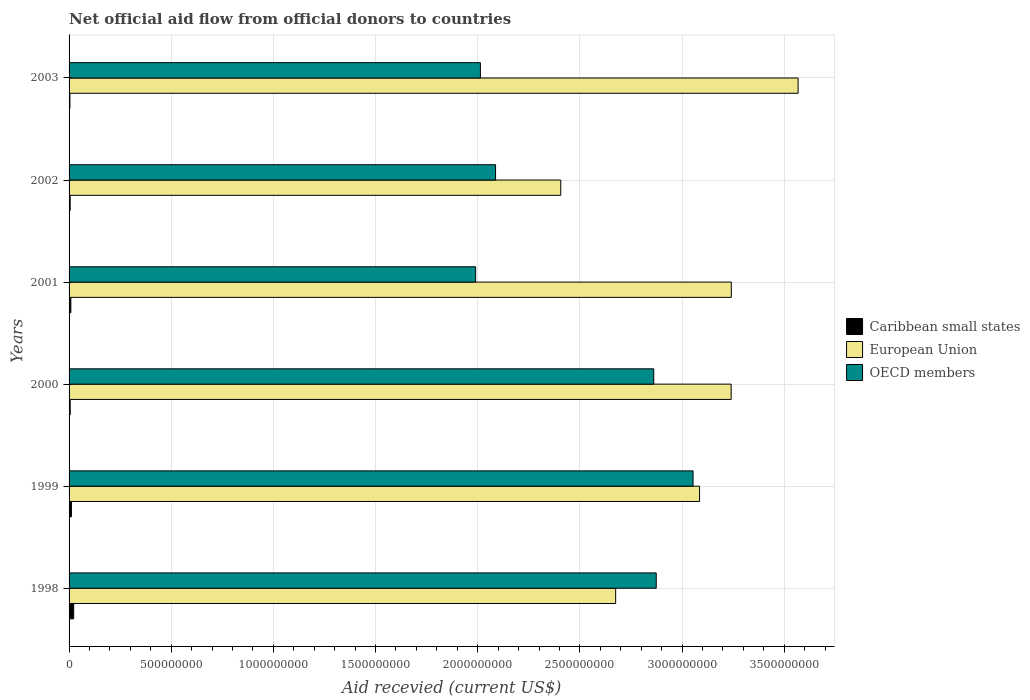How many groups of bars are there?
Offer a very short reply. 6. Are the number of bars per tick equal to the number of legend labels?
Your response must be concise. Yes. Are the number of bars on each tick of the Y-axis equal?
Your answer should be compact. Yes. How many bars are there on the 3rd tick from the bottom?
Ensure brevity in your answer.  3. What is the label of the 1st group of bars from the top?
Offer a terse response. 2003. What is the total aid received in European Union in 2003?
Provide a short and direct response. 3.57e+09. Across all years, what is the maximum total aid received in Caribbean small states?
Your response must be concise. 2.26e+07. Across all years, what is the minimum total aid received in OECD members?
Ensure brevity in your answer.  1.99e+09. In which year was the total aid received in OECD members minimum?
Your answer should be compact. 2001. What is the total total aid received in OECD members in the graph?
Provide a succinct answer. 1.49e+1. What is the difference between the total aid received in OECD members in 2002 and that in 2003?
Ensure brevity in your answer.  7.41e+07. What is the difference between the total aid received in Caribbean small states in 1998 and the total aid received in OECD members in 2001?
Ensure brevity in your answer.  -1.97e+09. What is the average total aid received in Caribbean small states per year?
Your answer should be compact. 9.62e+06. In the year 2002, what is the difference between the total aid received in European Union and total aid received in Caribbean small states?
Provide a succinct answer. 2.40e+09. In how many years, is the total aid received in European Union greater than 700000000 US$?
Make the answer very short. 6. What is the ratio of the total aid received in Caribbean small states in 1998 to that in 2001?
Provide a short and direct response. 2.6. What is the difference between the highest and the second highest total aid received in OECD members?
Your response must be concise. 1.80e+08. What is the difference between the highest and the lowest total aid received in European Union?
Provide a short and direct response. 1.16e+09. What does the 2nd bar from the top in 2001 represents?
Your answer should be very brief. European Union. What does the 2nd bar from the bottom in 2000 represents?
Your response must be concise. European Union. How many bars are there?
Provide a succinct answer. 18. What is the difference between two consecutive major ticks on the X-axis?
Ensure brevity in your answer.  5.00e+08. Are the values on the major ticks of X-axis written in scientific E-notation?
Offer a terse response. No. Where does the legend appear in the graph?
Give a very brief answer. Center right. What is the title of the graph?
Give a very brief answer. Net official aid flow from official donors to countries. Does "Curacao" appear as one of the legend labels in the graph?
Make the answer very short. No. What is the label or title of the X-axis?
Ensure brevity in your answer.  Aid recevied (current US$). What is the label or title of the Y-axis?
Offer a terse response. Years. What is the Aid recevied (current US$) of Caribbean small states in 1998?
Provide a succinct answer. 2.26e+07. What is the Aid recevied (current US$) of European Union in 1998?
Your answer should be compact. 2.68e+09. What is the Aid recevied (current US$) of OECD members in 1998?
Your answer should be compact. 2.87e+09. What is the Aid recevied (current US$) of Caribbean small states in 1999?
Ensure brevity in your answer.  1.16e+07. What is the Aid recevied (current US$) of European Union in 1999?
Your answer should be very brief. 3.09e+09. What is the Aid recevied (current US$) in OECD members in 1999?
Make the answer very short. 3.05e+09. What is the Aid recevied (current US$) in Caribbean small states in 2000?
Your answer should be compact. 5.47e+06. What is the Aid recevied (current US$) in European Union in 2000?
Offer a very short reply. 3.24e+09. What is the Aid recevied (current US$) of OECD members in 2000?
Provide a short and direct response. 2.86e+09. What is the Aid recevied (current US$) of Caribbean small states in 2001?
Provide a short and direct response. 8.68e+06. What is the Aid recevied (current US$) in European Union in 2001?
Offer a very short reply. 3.24e+09. What is the Aid recevied (current US$) in OECD members in 2001?
Offer a very short reply. 1.99e+09. What is the Aid recevied (current US$) in Caribbean small states in 2002?
Ensure brevity in your answer.  5.32e+06. What is the Aid recevied (current US$) of European Union in 2002?
Provide a succinct answer. 2.41e+09. What is the Aid recevied (current US$) of OECD members in 2002?
Ensure brevity in your answer.  2.09e+09. What is the Aid recevied (current US$) of Caribbean small states in 2003?
Provide a succinct answer. 4.07e+06. What is the Aid recevied (current US$) of European Union in 2003?
Your response must be concise. 3.57e+09. What is the Aid recevied (current US$) in OECD members in 2003?
Give a very brief answer. 2.01e+09. Across all years, what is the maximum Aid recevied (current US$) in Caribbean small states?
Make the answer very short. 2.26e+07. Across all years, what is the maximum Aid recevied (current US$) of European Union?
Offer a terse response. 3.57e+09. Across all years, what is the maximum Aid recevied (current US$) of OECD members?
Keep it short and to the point. 3.05e+09. Across all years, what is the minimum Aid recevied (current US$) of Caribbean small states?
Give a very brief answer. 4.07e+06. Across all years, what is the minimum Aid recevied (current US$) in European Union?
Your response must be concise. 2.41e+09. Across all years, what is the minimum Aid recevied (current US$) of OECD members?
Make the answer very short. 1.99e+09. What is the total Aid recevied (current US$) of Caribbean small states in the graph?
Offer a very short reply. 5.77e+07. What is the total Aid recevied (current US$) of European Union in the graph?
Your answer should be very brief. 1.82e+1. What is the total Aid recevied (current US$) of OECD members in the graph?
Offer a very short reply. 1.49e+1. What is the difference between the Aid recevied (current US$) of Caribbean small states in 1998 and that in 1999?
Your answer should be very brief. 1.10e+07. What is the difference between the Aid recevied (current US$) in European Union in 1998 and that in 1999?
Give a very brief answer. -4.11e+08. What is the difference between the Aid recevied (current US$) of OECD members in 1998 and that in 1999?
Your answer should be very brief. -1.80e+08. What is the difference between the Aid recevied (current US$) in Caribbean small states in 1998 and that in 2000?
Give a very brief answer. 1.71e+07. What is the difference between the Aid recevied (current US$) in European Union in 1998 and that in 2000?
Give a very brief answer. -5.65e+08. What is the difference between the Aid recevied (current US$) of OECD members in 1998 and that in 2000?
Ensure brevity in your answer.  1.22e+07. What is the difference between the Aid recevied (current US$) of Caribbean small states in 1998 and that in 2001?
Provide a succinct answer. 1.39e+07. What is the difference between the Aid recevied (current US$) in European Union in 1998 and that in 2001?
Make the answer very short. -5.66e+08. What is the difference between the Aid recevied (current US$) in OECD members in 1998 and that in 2001?
Keep it short and to the point. 8.84e+08. What is the difference between the Aid recevied (current US$) of Caribbean small states in 1998 and that in 2002?
Make the answer very short. 1.73e+07. What is the difference between the Aid recevied (current US$) of European Union in 1998 and that in 2002?
Your answer should be very brief. 2.69e+08. What is the difference between the Aid recevied (current US$) of OECD members in 1998 and that in 2002?
Your response must be concise. 7.86e+08. What is the difference between the Aid recevied (current US$) of Caribbean small states in 1998 and that in 2003?
Provide a succinct answer. 1.85e+07. What is the difference between the Aid recevied (current US$) in European Union in 1998 and that in 2003?
Offer a very short reply. -8.93e+08. What is the difference between the Aid recevied (current US$) in OECD members in 1998 and that in 2003?
Ensure brevity in your answer.  8.61e+08. What is the difference between the Aid recevied (current US$) of Caribbean small states in 1999 and that in 2000?
Make the answer very short. 6.09e+06. What is the difference between the Aid recevied (current US$) in European Union in 1999 and that in 2000?
Give a very brief answer. -1.55e+08. What is the difference between the Aid recevied (current US$) of OECD members in 1999 and that in 2000?
Ensure brevity in your answer.  1.92e+08. What is the difference between the Aid recevied (current US$) in Caribbean small states in 1999 and that in 2001?
Your response must be concise. 2.88e+06. What is the difference between the Aid recevied (current US$) in European Union in 1999 and that in 2001?
Your response must be concise. -1.55e+08. What is the difference between the Aid recevied (current US$) of OECD members in 1999 and that in 2001?
Offer a very short reply. 1.06e+09. What is the difference between the Aid recevied (current US$) of Caribbean small states in 1999 and that in 2002?
Offer a very short reply. 6.24e+06. What is the difference between the Aid recevied (current US$) of European Union in 1999 and that in 2002?
Your answer should be compact. 6.79e+08. What is the difference between the Aid recevied (current US$) in OECD members in 1999 and that in 2002?
Keep it short and to the point. 9.67e+08. What is the difference between the Aid recevied (current US$) in Caribbean small states in 1999 and that in 2003?
Offer a terse response. 7.49e+06. What is the difference between the Aid recevied (current US$) in European Union in 1999 and that in 2003?
Make the answer very short. -4.82e+08. What is the difference between the Aid recevied (current US$) in OECD members in 1999 and that in 2003?
Keep it short and to the point. 1.04e+09. What is the difference between the Aid recevied (current US$) in Caribbean small states in 2000 and that in 2001?
Your answer should be very brief. -3.21e+06. What is the difference between the Aid recevied (current US$) of European Union in 2000 and that in 2001?
Keep it short and to the point. -7.70e+05. What is the difference between the Aid recevied (current US$) of OECD members in 2000 and that in 2001?
Offer a very short reply. 8.72e+08. What is the difference between the Aid recevied (current US$) of Caribbean small states in 2000 and that in 2002?
Provide a succinct answer. 1.50e+05. What is the difference between the Aid recevied (current US$) in European Union in 2000 and that in 2002?
Provide a short and direct response. 8.34e+08. What is the difference between the Aid recevied (current US$) of OECD members in 2000 and that in 2002?
Make the answer very short. 7.74e+08. What is the difference between the Aid recevied (current US$) in Caribbean small states in 2000 and that in 2003?
Provide a succinct answer. 1.40e+06. What is the difference between the Aid recevied (current US$) in European Union in 2000 and that in 2003?
Make the answer very short. -3.28e+08. What is the difference between the Aid recevied (current US$) in OECD members in 2000 and that in 2003?
Provide a succinct answer. 8.48e+08. What is the difference between the Aid recevied (current US$) of Caribbean small states in 2001 and that in 2002?
Provide a succinct answer. 3.36e+06. What is the difference between the Aid recevied (current US$) of European Union in 2001 and that in 2002?
Your response must be concise. 8.35e+08. What is the difference between the Aid recevied (current US$) of OECD members in 2001 and that in 2002?
Your answer should be compact. -9.76e+07. What is the difference between the Aid recevied (current US$) in Caribbean small states in 2001 and that in 2003?
Give a very brief answer. 4.61e+06. What is the difference between the Aid recevied (current US$) of European Union in 2001 and that in 2003?
Keep it short and to the point. -3.27e+08. What is the difference between the Aid recevied (current US$) of OECD members in 2001 and that in 2003?
Offer a very short reply. -2.34e+07. What is the difference between the Aid recevied (current US$) of Caribbean small states in 2002 and that in 2003?
Ensure brevity in your answer.  1.25e+06. What is the difference between the Aid recevied (current US$) in European Union in 2002 and that in 2003?
Offer a terse response. -1.16e+09. What is the difference between the Aid recevied (current US$) of OECD members in 2002 and that in 2003?
Ensure brevity in your answer.  7.41e+07. What is the difference between the Aid recevied (current US$) in Caribbean small states in 1998 and the Aid recevied (current US$) in European Union in 1999?
Your answer should be very brief. -3.06e+09. What is the difference between the Aid recevied (current US$) of Caribbean small states in 1998 and the Aid recevied (current US$) of OECD members in 1999?
Provide a short and direct response. -3.03e+09. What is the difference between the Aid recevied (current US$) of European Union in 1998 and the Aid recevied (current US$) of OECD members in 1999?
Your response must be concise. -3.79e+08. What is the difference between the Aid recevied (current US$) of Caribbean small states in 1998 and the Aid recevied (current US$) of European Union in 2000?
Make the answer very short. -3.22e+09. What is the difference between the Aid recevied (current US$) in Caribbean small states in 1998 and the Aid recevied (current US$) in OECD members in 2000?
Ensure brevity in your answer.  -2.84e+09. What is the difference between the Aid recevied (current US$) in European Union in 1998 and the Aid recevied (current US$) in OECD members in 2000?
Your response must be concise. -1.86e+08. What is the difference between the Aid recevied (current US$) of Caribbean small states in 1998 and the Aid recevied (current US$) of European Union in 2001?
Provide a short and direct response. -3.22e+09. What is the difference between the Aid recevied (current US$) of Caribbean small states in 1998 and the Aid recevied (current US$) of OECD members in 2001?
Your answer should be compact. -1.97e+09. What is the difference between the Aid recevied (current US$) of European Union in 1998 and the Aid recevied (current US$) of OECD members in 2001?
Your response must be concise. 6.85e+08. What is the difference between the Aid recevied (current US$) of Caribbean small states in 1998 and the Aid recevied (current US$) of European Union in 2002?
Your answer should be compact. -2.38e+09. What is the difference between the Aid recevied (current US$) in Caribbean small states in 1998 and the Aid recevied (current US$) in OECD members in 2002?
Your response must be concise. -2.06e+09. What is the difference between the Aid recevied (current US$) in European Union in 1998 and the Aid recevied (current US$) in OECD members in 2002?
Keep it short and to the point. 5.88e+08. What is the difference between the Aid recevied (current US$) in Caribbean small states in 1998 and the Aid recevied (current US$) in European Union in 2003?
Provide a short and direct response. -3.55e+09. What is the difference between the Aid recevied (current US$) of Caribbean small states in 1998 and the Aid recevied (current US$) of OECD members in 2003?
Ensure brevity in your answer.  -1.99e+09. What is the difference between the Aid recevied (current US$) in European Union in 1998 and the Aid recevied (current US$) in OECD members in 2003?
Offer a terse response. 6.62e+08. What is the difference between the Aid recevied (current US$) in Caribbean small states in 1999 and the Aid recevied (current US$) in European Union in 2000?
Provide a short and direct response. -3.23e+09. What is the difference between the Aid recevied (current US$) in Caribbean small states in 1999 and the Aid recevied (current US$) in OECD members in 2000?
Your answer should be compact. -2.85e+09. What is the difference between the Aid recevied (current US$) in European Union in 1999 and the Aid recevied (current US$) in OECD members in 2000?
Keep it short and to the point. 2.24e+08. What is the difference between the Aid recevied (current US$) of Caribbean small states in 1999 and the Aid recevied (current US$) of European Union in 2001?
Keep it short and to the point. -3.23e+09. What is the difference between the Aid recevied (current US$) in Caribbean small states in 1999 and the Aid recevied (current US$) in OECD members in 2001?
Provide a short and direct response. -1.98e+09. What is the difference between the Aid recevied (current US$) in European Union in 1999 and the Aid recevied (current US$) in OECD members in 2001?
Keep it short and to the point. 1.10e+09. What is the difference between the Aid recevied (current US$) in Caribbean small states in 1999 and the Aid recevied (current US$) in European Union in 2002?
Provide a succinct answer. -2.39e+09. What is the difference between the Aid recevied (current US$) of Caribbean small states in 1999 and the Aid recevied (current US$) of OECD members in 2002?
Ensure brevity in your answer.  -2.08e+09. What is the difference between the Aid recevied (current US$) in European Union in 1999 and the Aid recevied (current US$) in OECD members in 2002?
Keep it short and to the point. 9.98e+08. What is the difference between the Aid recevied (current US$) in Caribbean small states in 1999 and the Aid recevied (current US$) in European Union in 2003?
Give a very brief answer. -3.56e+09. What is the difference between the Aid recevied (current US$) of Caribbean small states in 1999 and the Aid recevied (current US$) of OECD members in 2003?
Your answer should be compact. -2.00e+09. What is the difference between the Aid recevied (current US$) in European Union in 1999 and the Aid recevied (current US$) in OECD members in 2003?
Offer a very short reply. 1.07e+09. What is the difference between the Aid recevied (current US$) of Caribbean small states in 2000 and the Aid recevied (current US$) of European Union in 2001?
Give a very brief answer. -3.24e+09. What is the difference between the Aid recevied (current US$) of Caribbean small states in 2000 and the Aid recevied (current US$) of OECD members in 2001?
Make the answer very short. -1.98e+09. What is the difference between the Aid recevied (current US$) of European Union in 2000 and the Aid recevied (current US$) of OECD members in 2001?
Offer a terse response. 1.25e+09. What is the difference between the Aid recevied (current US$) of Caribbean small states in 2000 and the Aid recevied (current US$) of European Union in 2002?
Your answer should be compact. -2.40e+09. What is the difference between the Aid recevied (current US$) in Caribbean small states in 2000 and the Aid recevied (current US$) in OECD members in 2002?
Make the answer very short. -2.08e+09. What is the difference between the Aid recevied (current US$) of European Union in 2000 and the Aid recevied (current US$) of OECD members in 2002?
Provide a short and direct response. 1.15e+09. What is the difference between the Aid recevied (current US$) of Caribbean small states in 2000 and the Aid recevied (current US$) of European Union in 2003?
Your answer should be very brief. -3.56e+09. What is the difference between the Aid recevied (current US$) of Caribbean small states in 2000 and the Aid recevied (current US$) of OECD members in 2003?
Offer a terse response. -2.01e+09. What is the difference between the Aid recevied (current US$) in European Union in 2000 and the Aid recevied (current US$) in OECD members in 2003?
Keep it short and to the point. 1.23e+09. What is the difference between the Aid recevied (current US$) of Caribbean small states in 2001 and the Aid recevied (current US$) of European Union in 2002?
Provide a short and direct response. -2.40e+09. What is the difference between the Aid recevied (current US$) of Caribbean small states in 2001 and the Aid recevied (current US$) of OECD members in 2002?
Give a very brief answer. -2.08e+09. What is the difference between the Aid recevied (current US$) in European Union in 2001 and the Aid recevied (current US$) in OECD members in 2002?
Keep it short and to the point. 1.15e+09. What is the difference between the Aid recevied (current US$) of Caribbean small states in 2001 and the Aid recevied (current US$) of European Union in 2003?
Offer a terse response. -3.56e+09. What is the difference between the Aid recevied (current US$) in Caribbean small states in 2001 and the Aid recevied (current US$) in OECD members in 2003?
Your response must be concise. -2.00e+09. What is the difference between the Aid recevied (current US$) in European Union in 2001 and the Aid recevied (current US$) in OECD members in 2003?
Offer a terse response. 1.23e+09. What is the difference between the Aid recevied (current US$) in Caribbean small states in 2002 and the Aid recevied (current US$) in European Union in 2003?
Your answer should be compact. -3.56e+09. What is the difference between the Aid recevied (current US$) in Caribbean small states in 2002 and the Aid recevied (current US$) in OECD members in 2003?
Provide a succinct answer. -2.01e+09. What is the difference between the Aid recevied (current US$) in European Union in 2002 and the Aid recevied (current US$) in OECD members in 2003?
Your answer should be very brief. 3.93e+08. What is the average Aid recevied (current US$) in Caribbean small states per year?
Give a very brief answer. 9.62e+06. What is the average Aid recevied (current US$) in European Union per year?
Provide a short and direct response. 3.04e+09. What is the average Aid recevied (current US$) in OECD members per year?
Ensure brevity in your answer.  2.48e+09. In the year 1998, what is the difference between the Aid recevied (current US$) of Caribbean small states and Aid recevied (current US$) of European Union?
Give a very brief answer. -2.65e+09. In the year 1998, what is the difference between the Aid recevied (current US$) of Caribbean small states and Aid recevied (current US$) of OECD members?
Keep it short and to the point. -2.85e+09. In the year 1998, what is the difference between the Aid recevied (current US$) in European Union and Aid recevied (current US$) in OECD members?
Ensure brevity in your answer.  -1.99e+08. In the year 1999, what is the difference between the Aid recevied (current US$) of Caribbean small states and Aid recevied (current US$) of European Union?
Offer a very short reply. -3.07e+09. In the year 1999, what is the difference between the Aid recevied (current US$) in Caribbean small states and Aid recevied (current US$) in OECD members?
Give a very brief answer. -3.04e+09. In the year 1999, what is the difference between the Aid recevied (current US$) in European Union and Aid recevied (current US$) in OECD members?
Make the answer very short. 3.19e+07. In the year 2000, what is the difference between the Aid recevied (current US$) of Caribbean small states and Aid recevied (current US$) of European Union?
Your answer should be compact. -3.24e+09. In the year 2000, what is the difference between the Aid recevied (current US$) of Caribbean small states and Aid recevied (current US$) of OECD members?
Your answer should be very brief. -2.86e+09. In the year 2000, what is the difference between the Aid recevied (current US$) in European Union and Aid recevied (current US$) in OECD members?
Your answer should be very brief. 3.79e+08. In the year 2001, what is the difference between the Aid recevied (current US$) of Caribbean small states and Aid recevied (current US$) of European Union?
Make the answer very short. -3.23e+09. In the year 2001, what is the difference between the Aid recevied (current US$) in Caribbean small states and Aid recevied (current US$) in OECD members?
Offer a terse response. -1.98e+09. In the year 2001, what is the difference between the Aid recevied (current US$) in European Union and Aid recevied (current US$) in OECD members?
Provide a short and direct response. 1.25e+09. In the year 2002, what is the difference between the Aid recevied (current US$) in Caribbean small states and Aid recevied (current US$) in European Union?
Your response must be concise. -2.40e+09. In the year 2002, what is the difference between the Aid recevied (current US$) of Caribbean small states and Aid recevied (current US$) of OECD members?
Keep it short and to the point. -2.08e+09. In the year 2002, what is the difference between the Aid recevied (current US$) in European Union and Aid recevied (current US$) in OECD members?
Offer a very short reply. 3.19e+08. In the year 2003, what is the difference between the Aid recevied (current US$) in Caribbean small states and Aid recevied (current US$) in European Union?
Offer a very short reply. -3.56e+09. In the year 2003, what is the difference between the Aid recevied (current US$) in Caribbean small states and Aid recevied (current US$) in OECD members?
Offer a very short reply. -2.01e+09. In the year 2003, what is the difference between the Aid recevied (current US$) in European Union and Aid recevied (current US$) in OECD members?
Provide a succinct answer. 1.55e+09. What is the ratio of the Aid recevied (current US$) of Caribbean small states in 1998 to that in 1999?
Provide a succinct answer. 1.96. What is the ratio of the Aid recevied (current US$) of European Union in 1998 to that in 1999?
Give a very brief answer. 0.87. What is the ratio of the Aid recevied (current US$) in OECD members in 1998 to that in 1999?
Your answer should be very brief. 0.94. What is the ratio of the Aid recevied (current US$) in Caribbean small states in 1998 to that in 2000?
Your answer should be compact. 4.13. What is the ratio of the Aid recevied (current US$) of European Union in 1998 to that in 2000?
Make the answer very short. 0.83. What is the ratio of the Aid recevied (current US$) of Caribbean small states in 1998 to that in 2001?
Your answer should be compact. 2.6. What is the ratio of the Aid recevied (current US$) of European Union in 1998 to that in 2001?
Offer a very short reply. 0.83. What is the ratio of the Aid recevied (current US$) of OECD members in 1998 to that in 2001?
Offer a very short reply. 1.44. What is the ratio of the Aid recevied (current US$) in Caribbean small states in 1998 to that in 2002?
Offer a terse response. 4.25. What is the ratio of the Aid recevied (current US$) of European Union in 1998 to that in 2002?
Your response must be concise. 1.11. What is the ratio of the Aid recevied (current US$) in OECD members in 1998 to that in 2002?
Offer a terse response. 1.38. What is the ratio of the Aid recevied (current US$) in Caribbean small states in 1998 to that in 2003?
Provide a succinct answer. 5.56. What is the ratio of the Aid recevied (current US$) in European Union in 1998 to that in 2003?
Provide a short and direct response. 0.75. What is the ratio of the Aid recevied (current US$) of OECD members in 1998 to that in 2003?
Provide a succinct answer. 1.43. What is the ratio of the Aid recevied (current US$) in Caribbean small states in 1999 to that in 2000?
Keep it short and to the point. 2.11. What is the ratio of the Aid recevied (current US$) of European Union in 1999 to that in 2000?
Ensure brevity in your answer.  0.95. What is the ratio of the Aid recevied (current US$) of OECD members in 1999 to that in 2000?
Offer a terse response. 1.07. What is the ratio of the Aid recevied (current US$) in Caribbean small states in 1999 to that in 2001?
Your answer should be very brief. 1.33. What is the ratio of the Aid recevied (current US$) in OECD members in 1999 to that in 2001?
Keep it short and to the point. 1.53. What is the ratio of the Aid recevied (current US$) of Caribbean small states in 1999 to that in 2002?
Your response must be concise. 2.17. What is the ratio of the Aid recevied (current US$) in European Union in 1999 to that in 2002?
Offer a terse response. 1.28. What is the ratio of the Aid recevied (current US$) of OECD members in 1999 to that in 2002?
Your answer should be compact. 1.46. What is the ratio of the Aid recevied (current US$) in Caribbean small states in 1999 to that in 2003?
Offer a very short reply. 2.84. What is the ratio of the Aid recevied (current US$) in European Union in 1999 to that in 2003?
Offer a terse response. 0.86. What is the ratio of the Aid recevied (current US$) of OECD members in 1999 to that in 2003?
Keep it short and to the point. 1.52. What is the ratio of the Aid recevied (current US$) of Caribbean small states in 2000 to that in 2001?
Your response must be concise. 0.63. What is the ratio of the Aid recevied (current US$) in OECD members in 2000 to that in 2001?
Provide a short and direct response. 1.44. What is the ratio of the Aid recevied (current US$) of Caribbean small states in 2000 to that in 2002?
Your answer should be compact. 1.03. What is the ratio of the Aid recevied (current US$) of European Union in 2000 to that in 2002?
Offer a terse response. 1.35. What is the ratio of the Aid recevied (current US$) of OECD members in 2000 to that in 2002?
Ensure brevity in your answer.  1.37. What is the ratio of the Aid recevied (current US$) of Caribbean small states in 2000 to that in 2003?
Provide a succinct answer. 1.34. What is the ratio of the Aid recevied (current US$) of European Union in 2000 to that in 2003?
Offer a terse response. 0.91. What is the ratio of the Aid recevied (current US$) in OECD members in 2000 to that in 2003?
Ensure brevity in your answer.  1.42. What is the ratio of the Aid recevied (current US$) of Caribbean small states in 2001 to that in 2002?
Your answer should be compact. 1.63. What is the ratio of the Aid recevied (current US$) in European Union in 2001 to that in 2002?
Make the answer very short. 1.35. What is the ratio of the Aid recevied (current US$) in OECD members in 2001 to that in 2002?
Offer a terse response. 0.95. What is the ratio of the Aid recevied (current US$) of Caribbean small states in 2001 to that in 2003?
Your response must be concise. 2.13. What is the ratio of the Aid recevied (current US$) in European Union in 2001 to that in 2003?
Provide a short and direct response. 0.91. What is the ratio of the Aid recevied (current US$) in OECD members in 2001 to that in 2003?
Keep it short and to the point. 0.99. What is the ratio of the Aid recevied (current US$) of Caribbean small states in 2002 to that in 2003?
Provide a succinct answer. 1.31. What is the ratio of the Aid recevied (current US$) in European Union in 2002 to that in 2003?
Your answer should be compact. 0.67. What is the ratio of the Aid recevied (current US$) in OECD members in 2002 to that in 2003?
Make the answer very short. 1.04. What is the difference between the highest and the second highest Aid recevied (current US$) in Caribbean small states?
Keep it short and to the point. 1.10e+07. What is the difference between the highest and the second highest Aid recevied (current US$) in European Union?
Offer a very short reply. 3.27e+08. What is the difference between the highest and the second highest Aid recevied (current US$) in OECD members?
Your answer should be very brief. 1.80e+08. What is the difference between the highest and the lowest Aid recevied (current US$) in Caribbean small states?
Give a very brief answer. 1.85e+07. What is the difference between the highest and the lowest Aid recevied (current US$) of European Union?
Keep it short and to the point. 1.16e+09. What is the difference between the highest and the lowest Aid recevied (current US$) in OECD members?
Make the answer very short. 1.06e+09. 